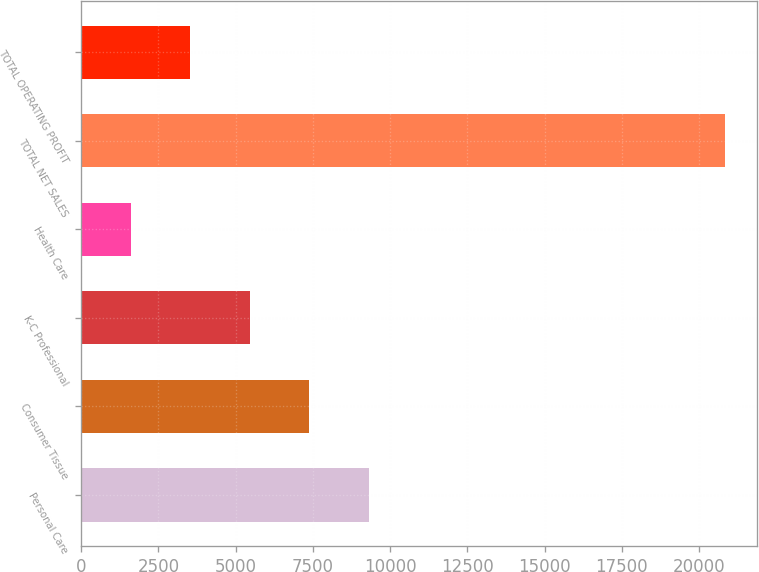<chart> <loc_0><loc_0><loc_500><loc_500><bar_chart><fcel>Personal Care<fcel>Consumer Tissue<fcel>K-C Professional<fcel>Health Care<fcel>TOTAL NET SALES<fcel>TOTAL OPERATING PROFIT<nl><fcel>9302<fcel>7378<fcel>5454<fcel>1606<fcel>20846<fcel>3530<nl></chart> 